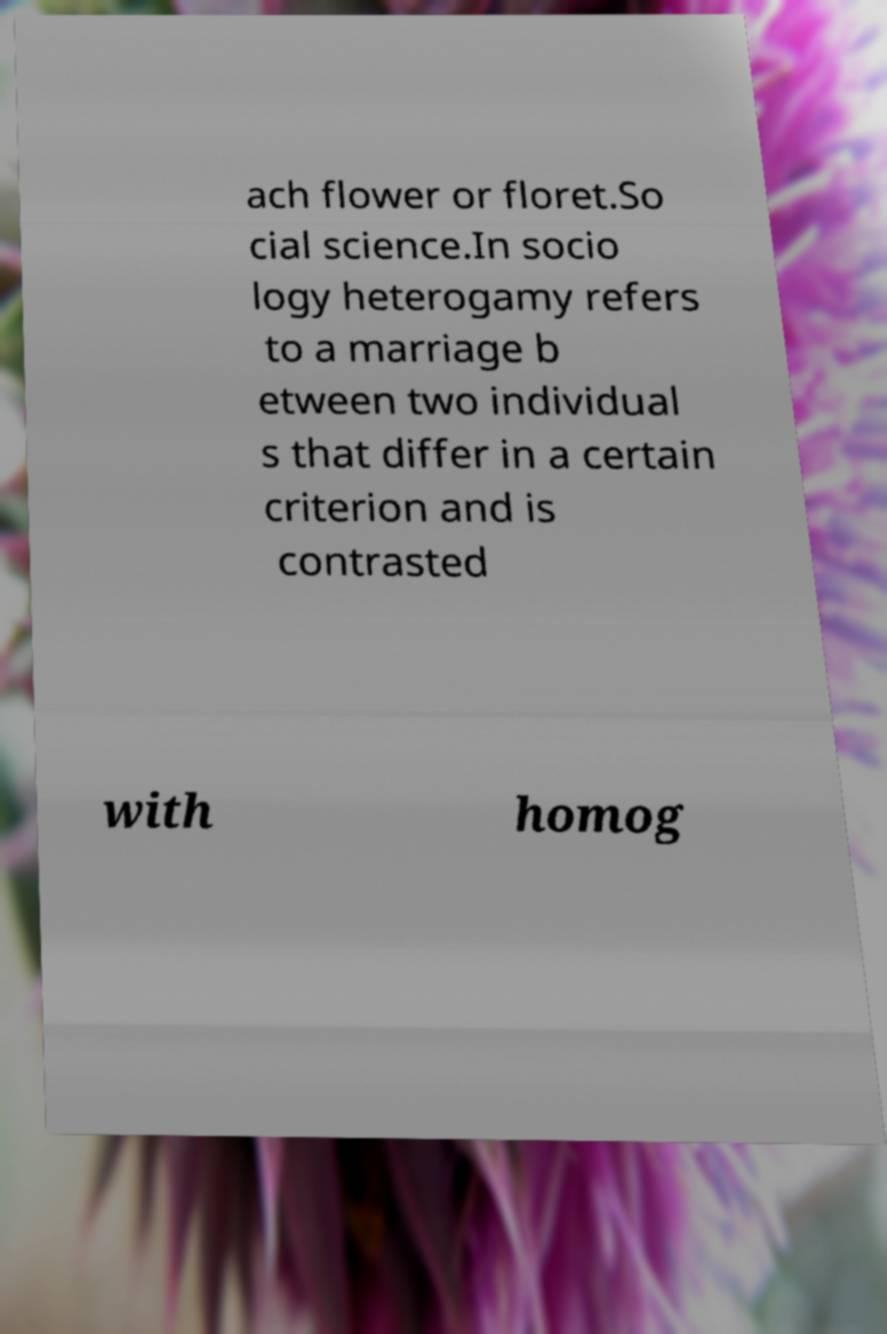Could you extract and type out the text from this image? ach flower or floret.So cial science.In socio logy heterogamy refers to a marriage b etween two individual s that differ in a certain criterion and is contrasted with homog 